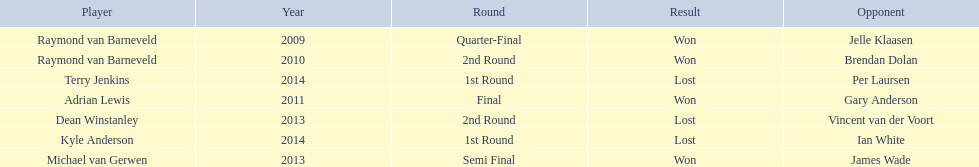Who were the players in 2014? Terry Jenkins, Kyle Anderson. Did they win or lose? Per Laursen. 